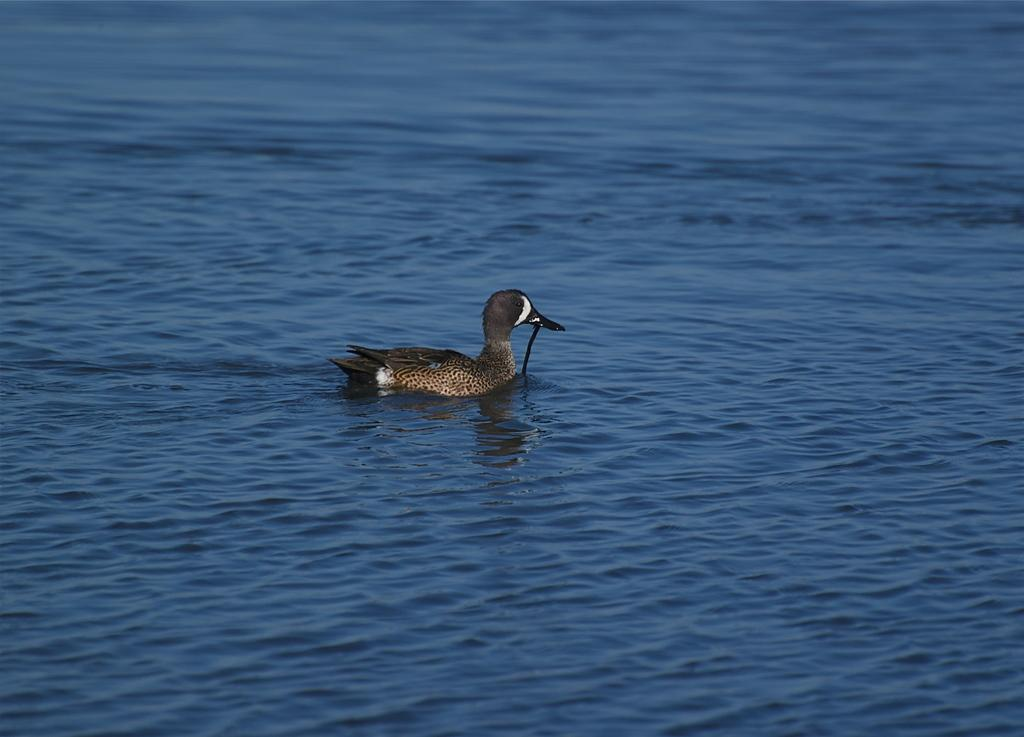What animal is present in the image? There is a duck in the image. Where is the duck located? The duck is in the water. What type of lipstick is the duck wearing in the image? There is no lipstick or any indication of makeup on the duck in the image. 